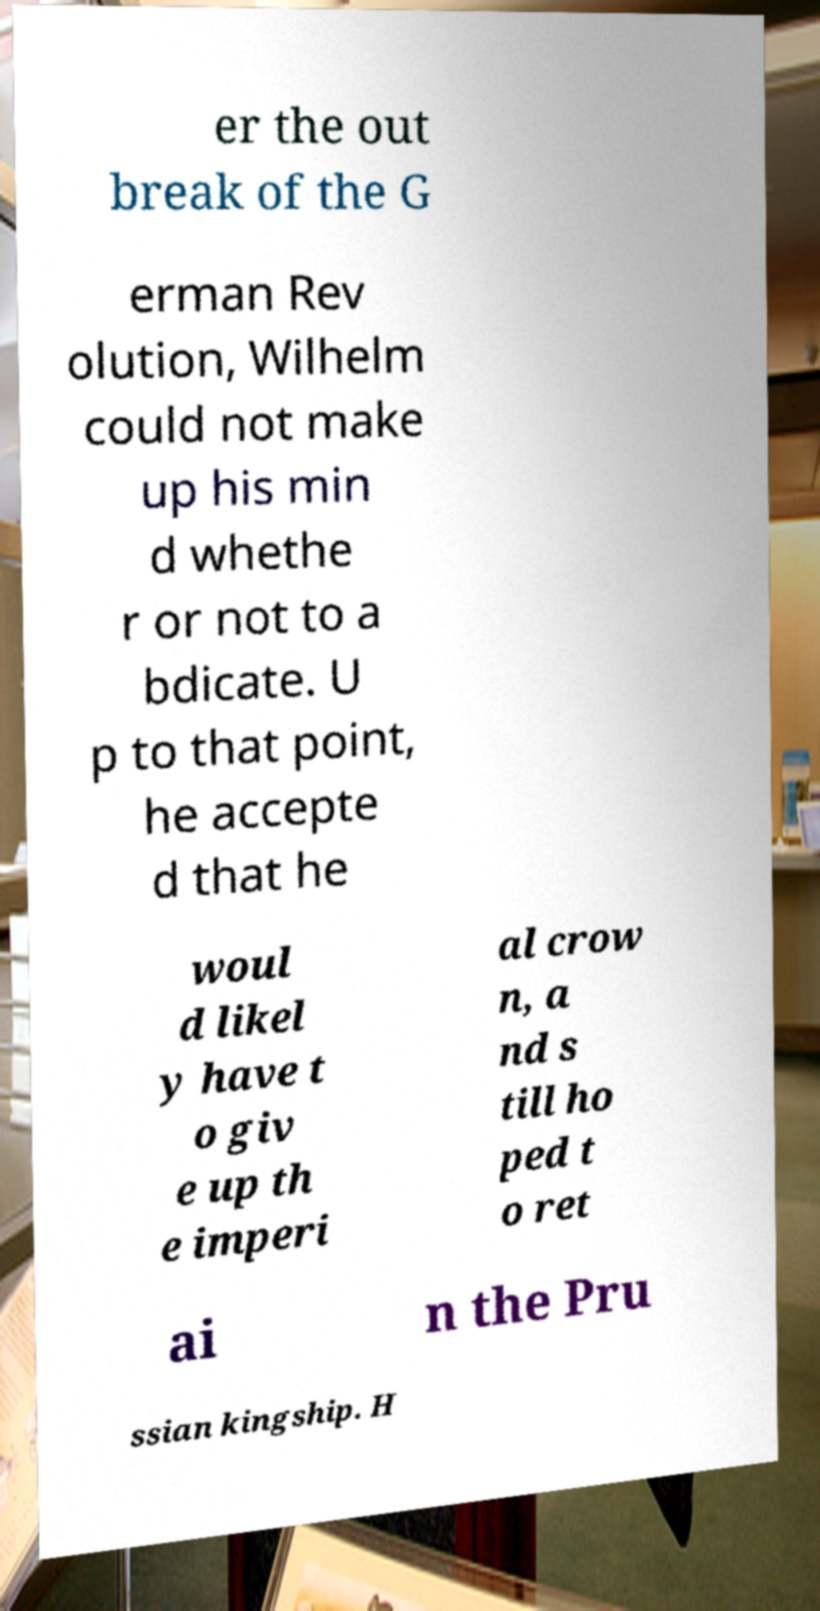Could you assist in decoding the text presented in this image and type it out clearly? er the out break of the G erman Rev olution, Wilhelm could not make up his min d whethe r or not to a bdicate. U p to that point, he accepte d that he woul d likel y have t o giv e up th e imperi al crow n, a nd s till ho ped t o ret ai n the Pru ssian kingship. H 